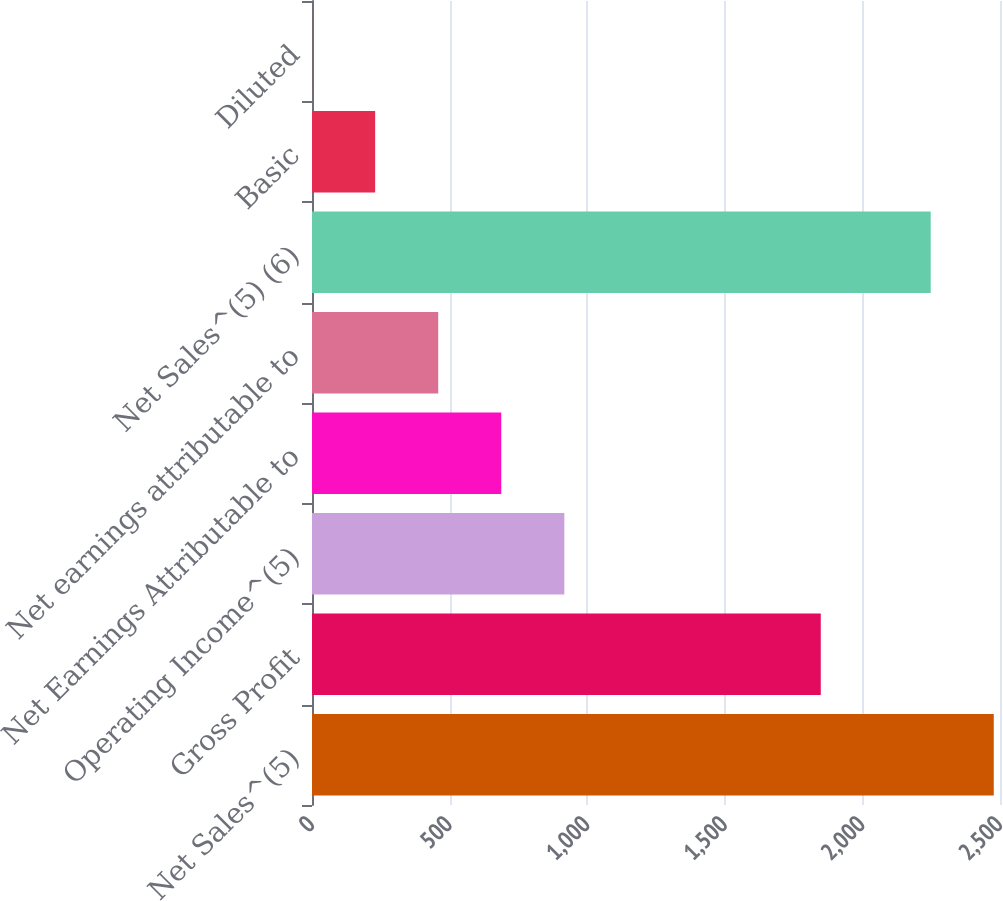Convert chart. <chart><loc_0><loc_0><loc_500><loc_500><bar_chart><fcel>Net Sales^(5)<fcel>Gross Profit<fcel>Operating Income^(5)<fcel>Net Earnings Attributable to<fcel>Net earnings attributable to<fcel>Net Sales^(5) (6)<fcel>Basic<fcel>Diluted<nl><fcel>2477.35<fcel>1848.7<fcel>916.93<fcel>687.78<fcel>458.63<fcel>2248.2<fcel>229.48<fcel>0.33<nl></chart> 